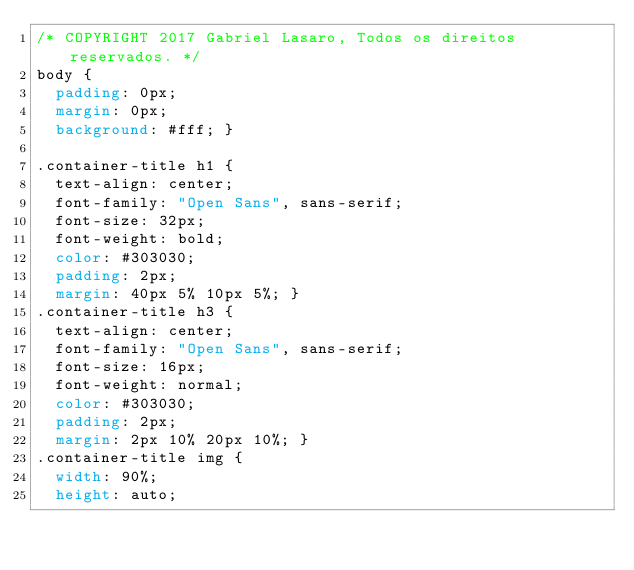<code> <loc_0><loc_0><loc_500><loc_500><_CSS_>/* COPYRIGHT 2017 Gabriel Lasaro, Todos os direitos reservados. */
body {
  padding: 0px;
  margin: 0px;
  background: #fff; }

.container-title h1 {
  text-align: center;
  font-family: "Open Sans", sans-serif;
  font-size: 32px;
  font-weight: bold;
  color: #303030;
  padding: 2px;
  margin: 40px 5% 10px 5%; }
.container-title h3 {
  text-align: center;
  font-family: "Open Sans", sans-serif;
  font-size: 16px;
  font-weight: normal;
  color: #303030;
  padding: 2px;
  margin: 2px 10% 20px 10%; }
.container-title img {
  width: 90%;
  height: auto;</code> 